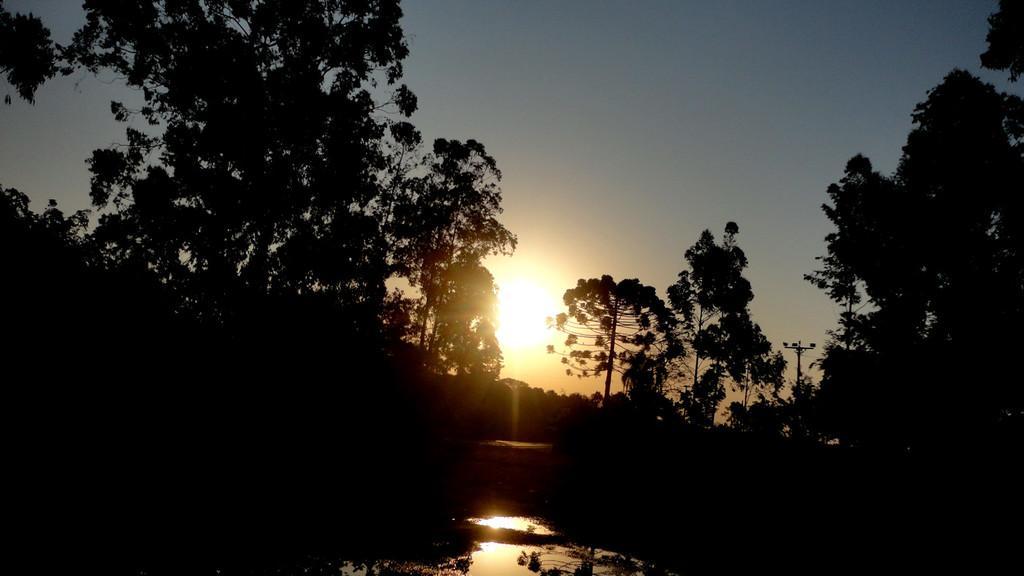Please provide a concise description of this image. In this image I can see trees, sun set and the sky ,this picture is very dark 